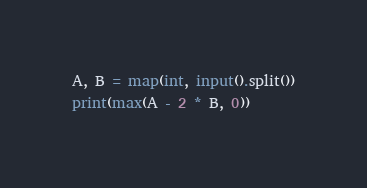<code> <loc_0><loc_0><loc_500><loc_500><_Python_>A, B = map(int, input().split())
print(max(A - 2 * B, 0))
</code> 